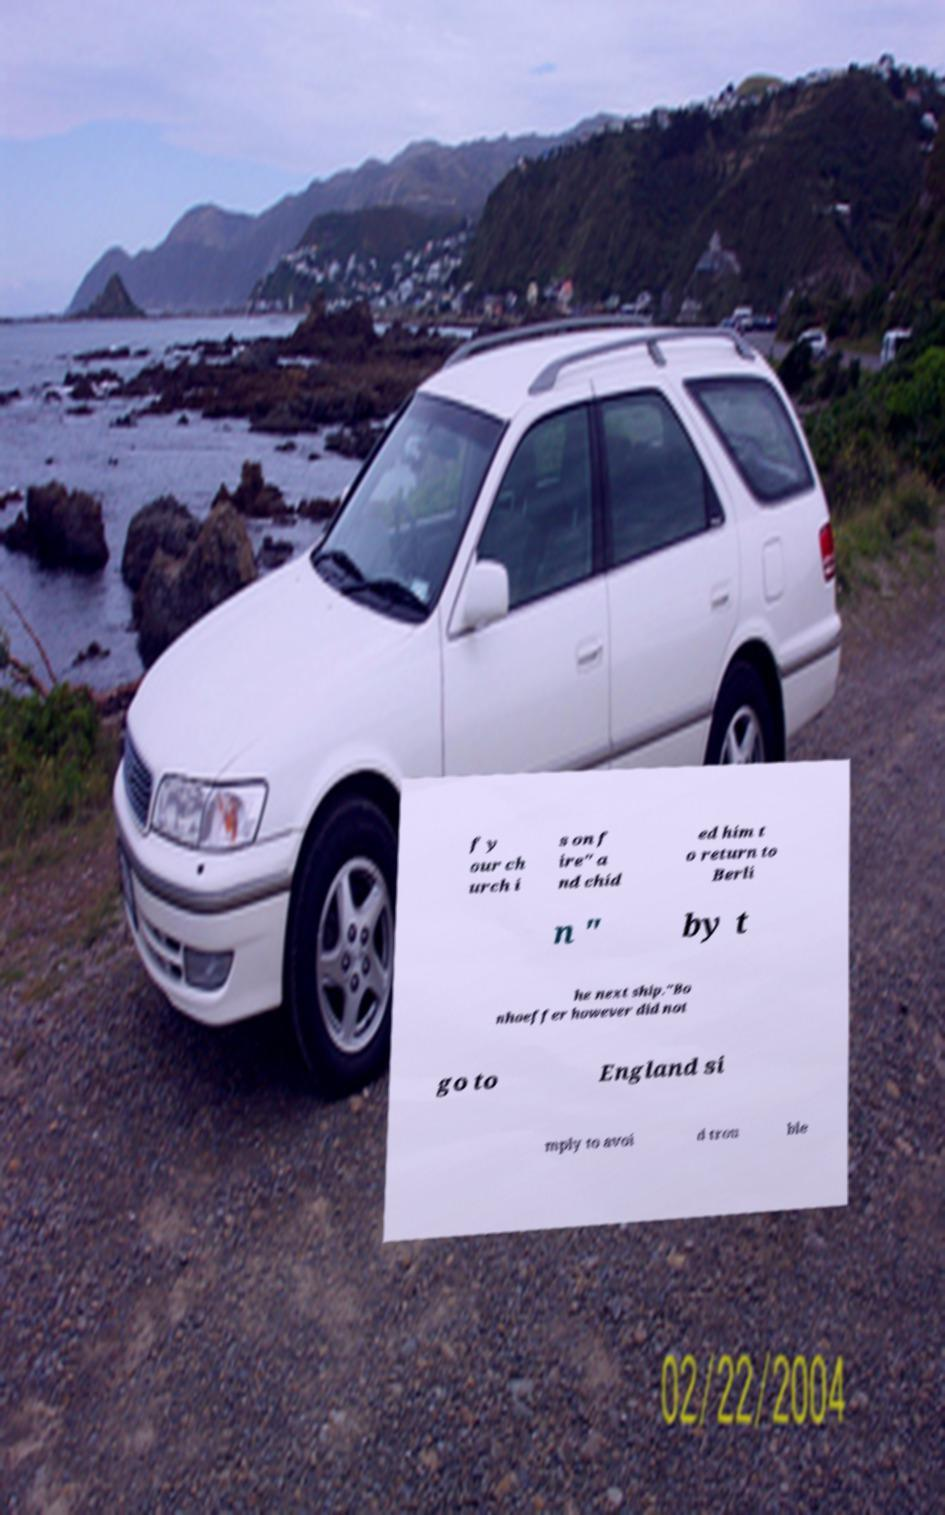There's text embedded in this image that I need extracted. Can you transcribe it verbatim? f y our ch urch i s on f ire" a nd chid ed him t o return to Berli n " by t he next ship."Bo nhoeffer however did not go to England si mply to avoi d trou ble 